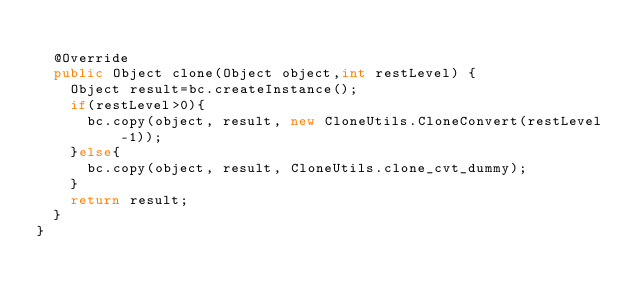<code> <loc_0><loc_0><loc_500><loc_500><_Java_>
	@Override
	public Object clone(Object object,int restLevel) {
		Object result=bc.createInstance();
		if(restLevel>0){
			bc.copy(object, result, new CloneUtils.CloneConvert(restLevel-1));
		}else{
			bc.copy(object, result, CloneUtils.clone_cvt_dummy);
		}
		return result;
	}
}
</code> 